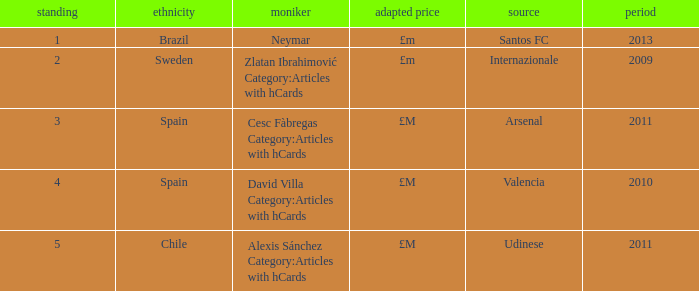What is the name of the player from Spain with a rank lower than 3? David Villa Category:Articles with hCards. 